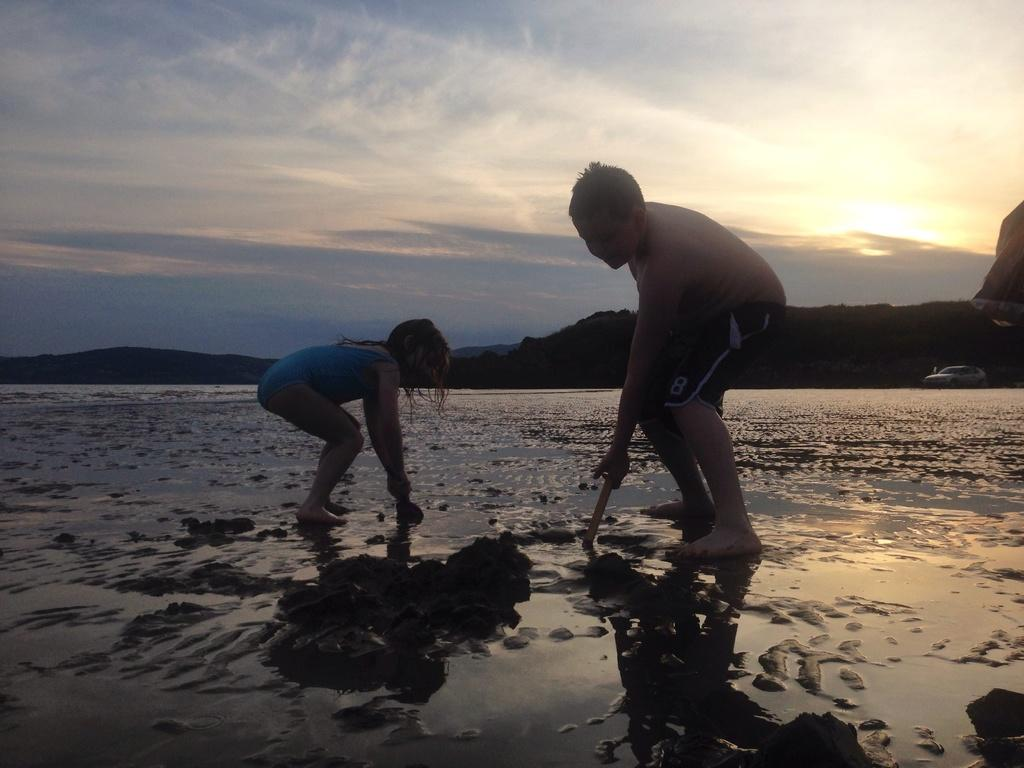Who is present in the image? There is a boy and a girl in the image. What are the boy and the girl doing? Both the boy and the girl are playing. Where is the location of the image? The location is on the side of a beach. What can be seen in the background of the image? There are hills in the background of the image. What is visible in the sky in the image? The sky is visible in the image, and clouds are present. How many people are falling off the sand dunes in the image? There are no people falling off sand dunes in the image; it features a boy and a girl playing on the side of a beach. 